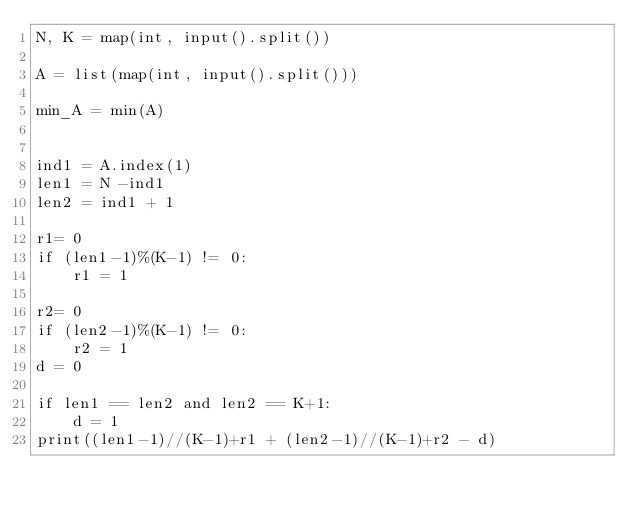<code> <loc_0><loc_0><loc_500><loc_500><_Python_>N, K = map(int, input().split())

A = list(map(int, input().split()))

min_A = min(A)


ind1 = A.index(1)
len1 = N -ind1
len2 = ind1 + 1

r1= 0
if (len1-1)%(K-1) != 0:
    r1 = 1

r2= 0
if (len2-1)%(K-1) != 0:
    r2 = 1
d = 0

if len1 == len2 and len2 == K+1:
    d = 1
print((len1-1)//(K-1)+r1 + (len2-1)//(K-1)+r2 - d)
</code> 